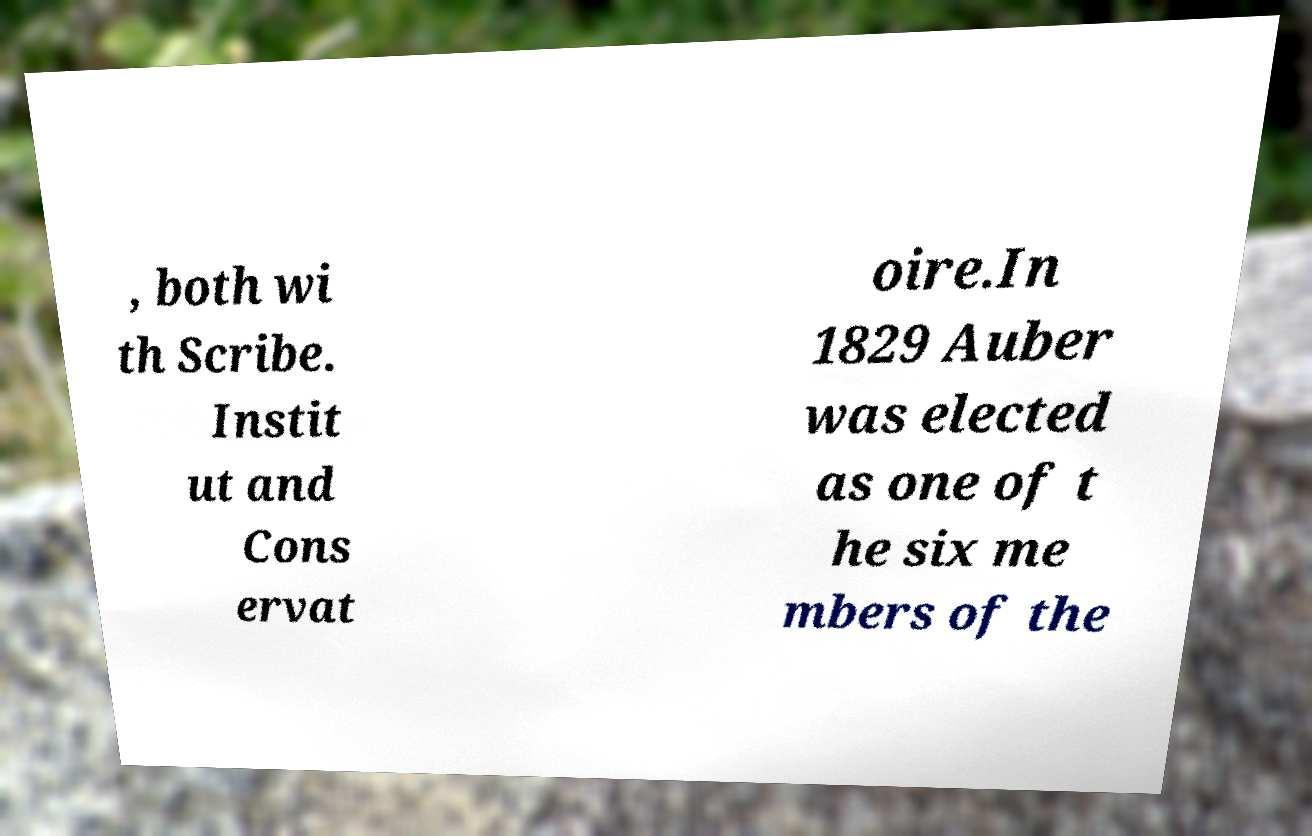What messages or text are displayed in this image? I need them in a readable, typed format. , both wi th Scribe. Instit ut and Cons ervat oire.In 1829 Auber was elected as one of t he six me mbers of the 